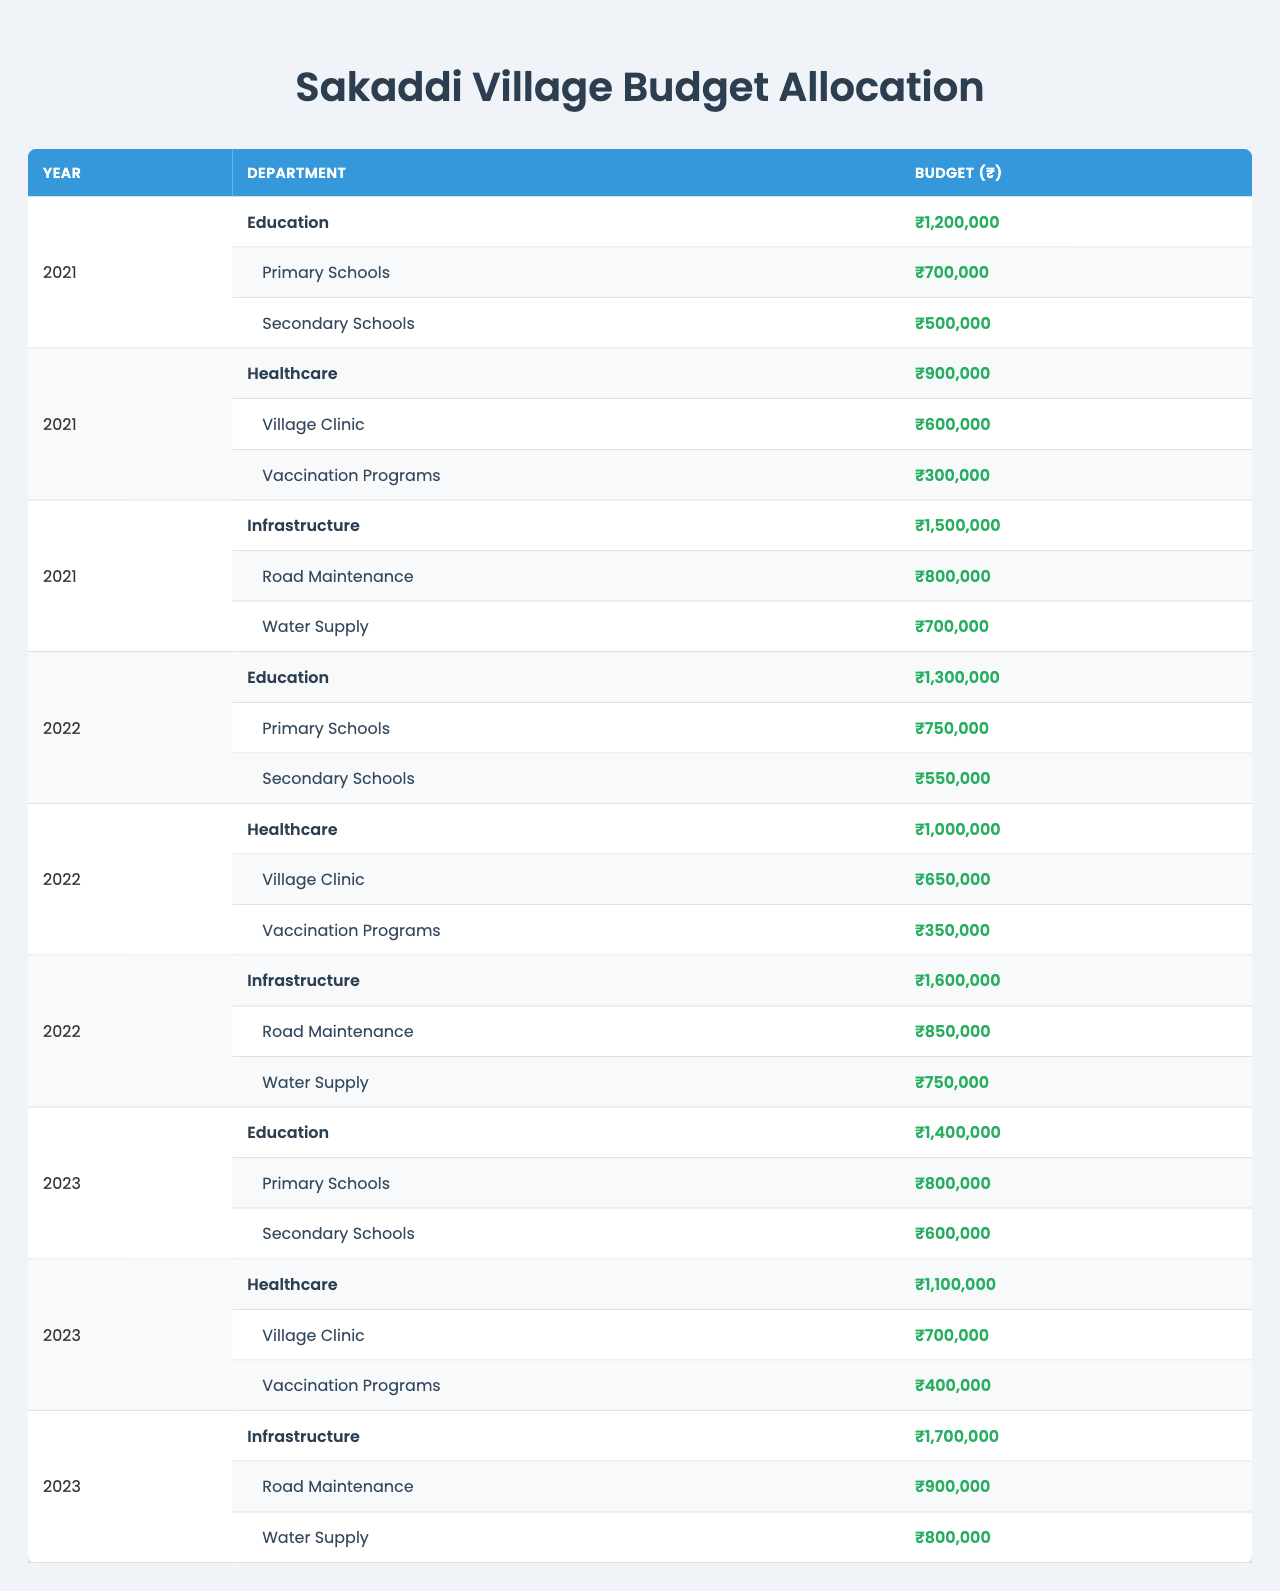What is the total budget allocated for Education in 2022? The budget for Education in 2022 is ₹1,300,000. This is directly stated in the table.
Answer: ₹1,300,000 How much budget was allocated to the Village Clinic in 2023? The Village Clinic received a budget of ₹700,000 in 2023 as noted in the healthcare department section for that year.
Answer: ₹700,000 Which year had the highest total budget for Infrastructure? By comparing the Infrastructure budgets across the three years, 2023 has the highest total budget of ₹1,700,000. This is evident by observing and comparing the Infrastructure budgets listed.
Answer: 2023 What is the average budget allocated to Secondary Schools over the three years? The budget for Secondary Schools across the three years is ₹500,000 (2021), ₹550,000 (2022), and ₹600,000 (2023). Summing these gives ₹1,650,000. Dividing by 3 (the number of years) results in an average of ₹550,000.
Answer: ₹550,000 Is the budget for Vaccination Programs increasing each year? Looking at the allocation for Vaccination Programs over the three years: ₹300,000 (2021), ₹350,000 (2022), and ₹400,000 (2023), we see a consistent increase each year. Hence, it is true that the budget is increasing.
Answer: Yes What is the difference between the total budget for Healthcare in 2021 and 2023? The total Healthcare budget for 2021 is ₹900,000 and for 2023 it is ₹1,100,000. Calculating the difference: ₹1,100,000 - ₹900,000 = ₹200,000.
Answer: ₹200,000 Which has a higher budget in 2022: Primary Schools or Road Maintenance? The budget for Primary Schools in 2022 is ₹750,000 and for Road Maintenance it is ₹850,000. Comparing these amounts shows that Road Maintenance has a higher budget.
Answer: Road Maintenance How much total budget was allocated to all departments in 2021? The total budget allocation in 2021 is calculated as follows: Education (₹1,200,000) + Healthcare (₹900,000) + Infrastructure (₹1,500,000) = ₹3,600,000.
Answer: ₹3,600,000 What is the budget allocated to Water Supply in 2023? The budget allocated to Water Supply in 2023, as mentioned under the Infrastructure department in that year, is ₹800,000.
Answer: ₹800,000 In which year was the total budget for Infrastructure closest to ₹1,600,000? By reviewing the budgets across the years, the total budget for Infrastructure was ₹1,500,000 in 2021 and ₹1,600,000 in 2022. Thus, 2022 is the year where it is closest to ₹1,600,000.
Answer: 2022 